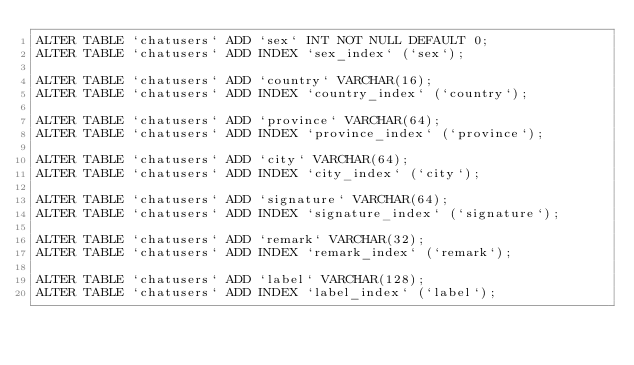<code> <loc_0><loc_0><loc_500><loc_500><_SQL_>ALTER TABLE `chatusers` ADD `sex` INT NOT NULL DEFAULT 0;
ALTER TABLE `chatusers` ADD INDEX `sex_index` (`sex`);

ALTER TABLE `chatusers` ADD `country` VARCHAR(16);
ALTER TABLE `chatusers` ADD INDEX `country_index` (`country`);

ALTER TABLE `chatusers` ADD `province` VARCHAR(64);
ALTER TABLE `chatusers` ADD INDEX `province_index` (`province`);

ALTER TABLE `chatusers` ADD `city` VARCHAR(64);
ALTER TABLE `chatusers` ADD INDEX `city_index` (`city`);

ALTER TABLE `chatusers` ADD `signature` VARCHAR(64);
ALTER TABLE `chatusers` ADD INDEX `signature_index` (`signature`);

ALTER TABLE `chatusers` ADD `remark` VARCHAR(32);
ALTER TABLE `chatusers` ADD INDEX `remark_index` (`remark`);

ALTER TABLE `chatusers` ADD `label` VARCHAR(128);
ALTER TABLE `chatusers` ADD INDEX `label_index` (`label`);




</code> 